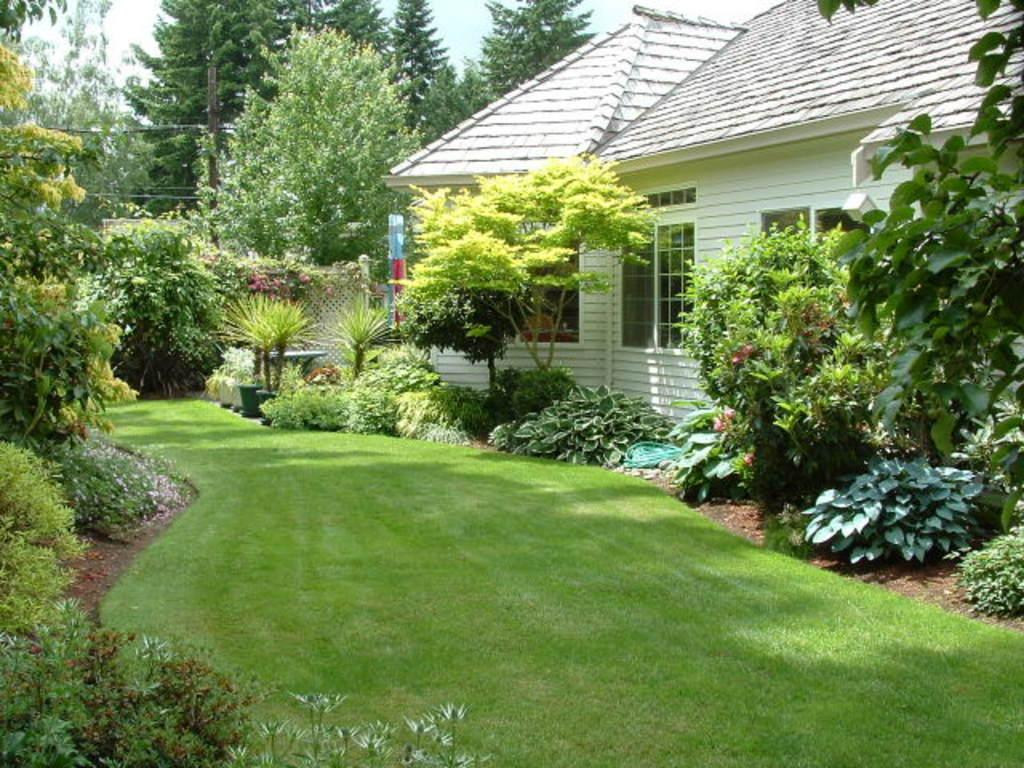What type of structures can be seen in the image? There are sheds in the image. What other natural elements are present in the image? There are trees and grass visible in the image. What is the purpose of the pole with wires in the image? The pole with wires is likely used for electrical or communication purposes. What can be seen in the background of the image? The sky is visible in the background of the image. Can you see anyone wearing a hat in the image? There is no hat visible in the image. How many times does the person in the image kick the ball? There is no person or ball present in the image. 